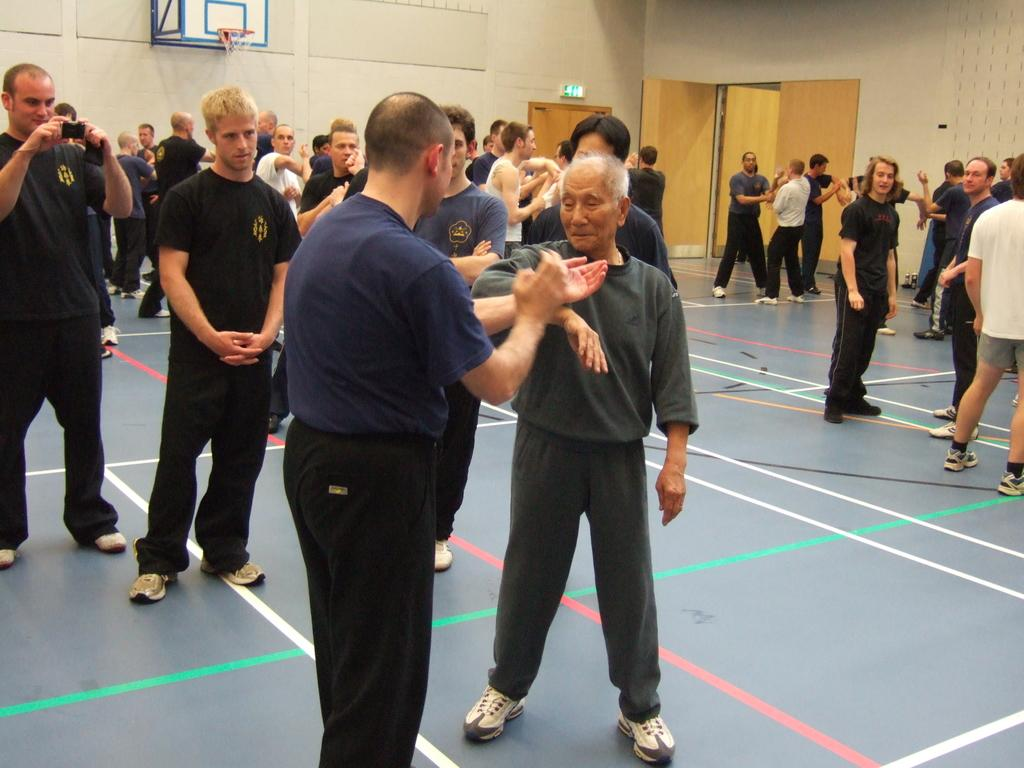What is happening in the center of the image? There are many people standing in the center of the image. Where is the man located in the image? The man is standing on the left side of the image. What is the man holding in the image? The man is holding a mobile. What can be seen in the background of the image? There is a wall, a door, and a net visible in the background of the image. Are there any kittens causing trouble in the image? There are no kittens present in the image, and therefore no trouble can be observed. Is this a birthday celebration in the image? There is no indication in the image that it is a birthday celebration. 